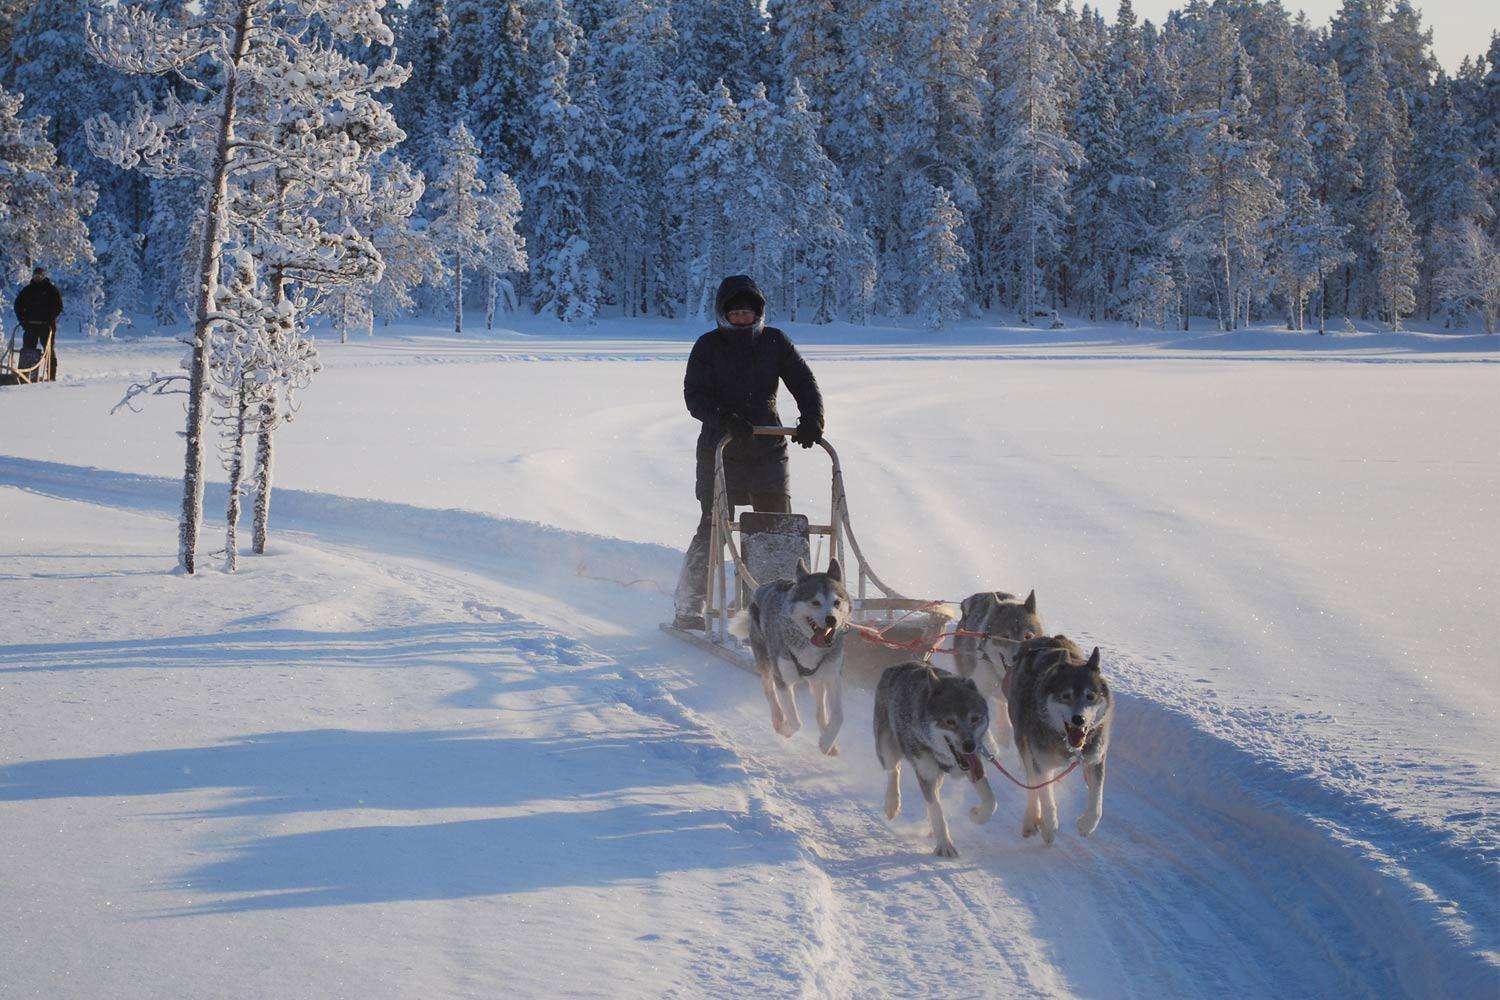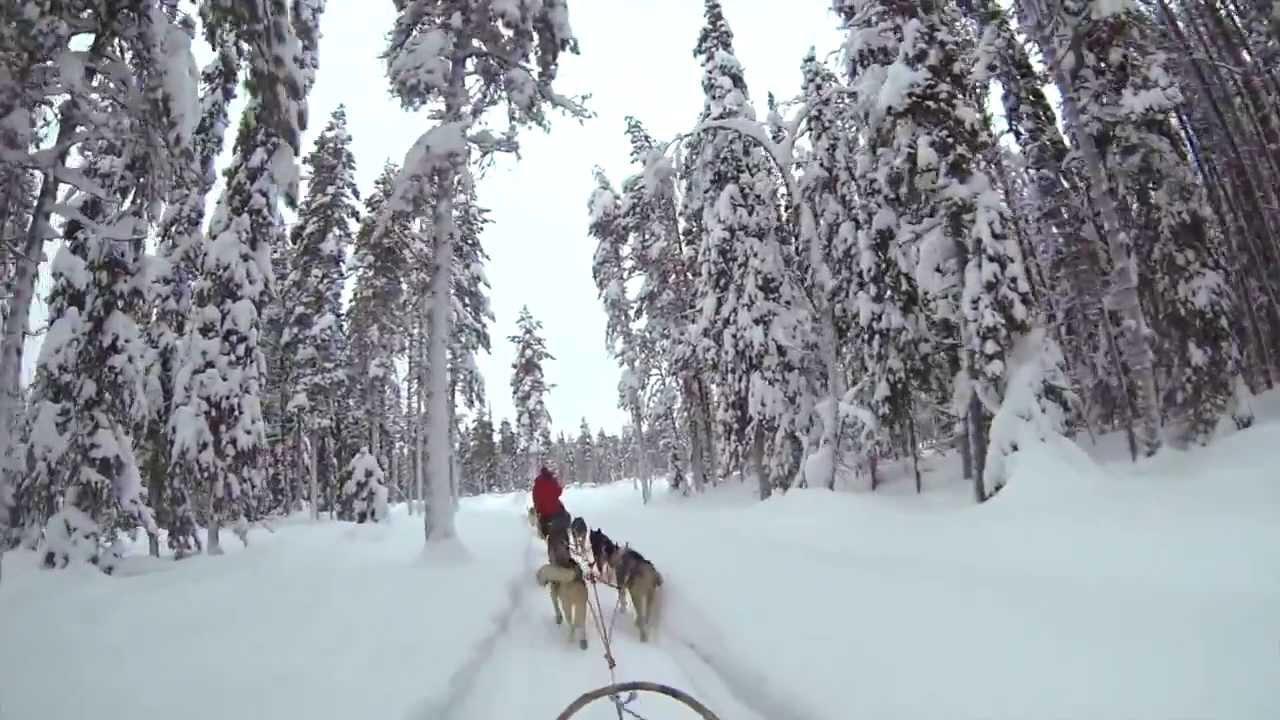The first image is the image on the left, the second image is the image on the right. Considering the images on both sides, is "In both images, the sled dogs are heading in nearly the same direction." valid? Answer yes or no. No. The first image is the image on the left, the second image is the image on the right. Analyze the images presented: Is the assertion "In one image, dog sleds are traveling close to and between large snow covered trees." valid? Answer yes or no. Yes. 